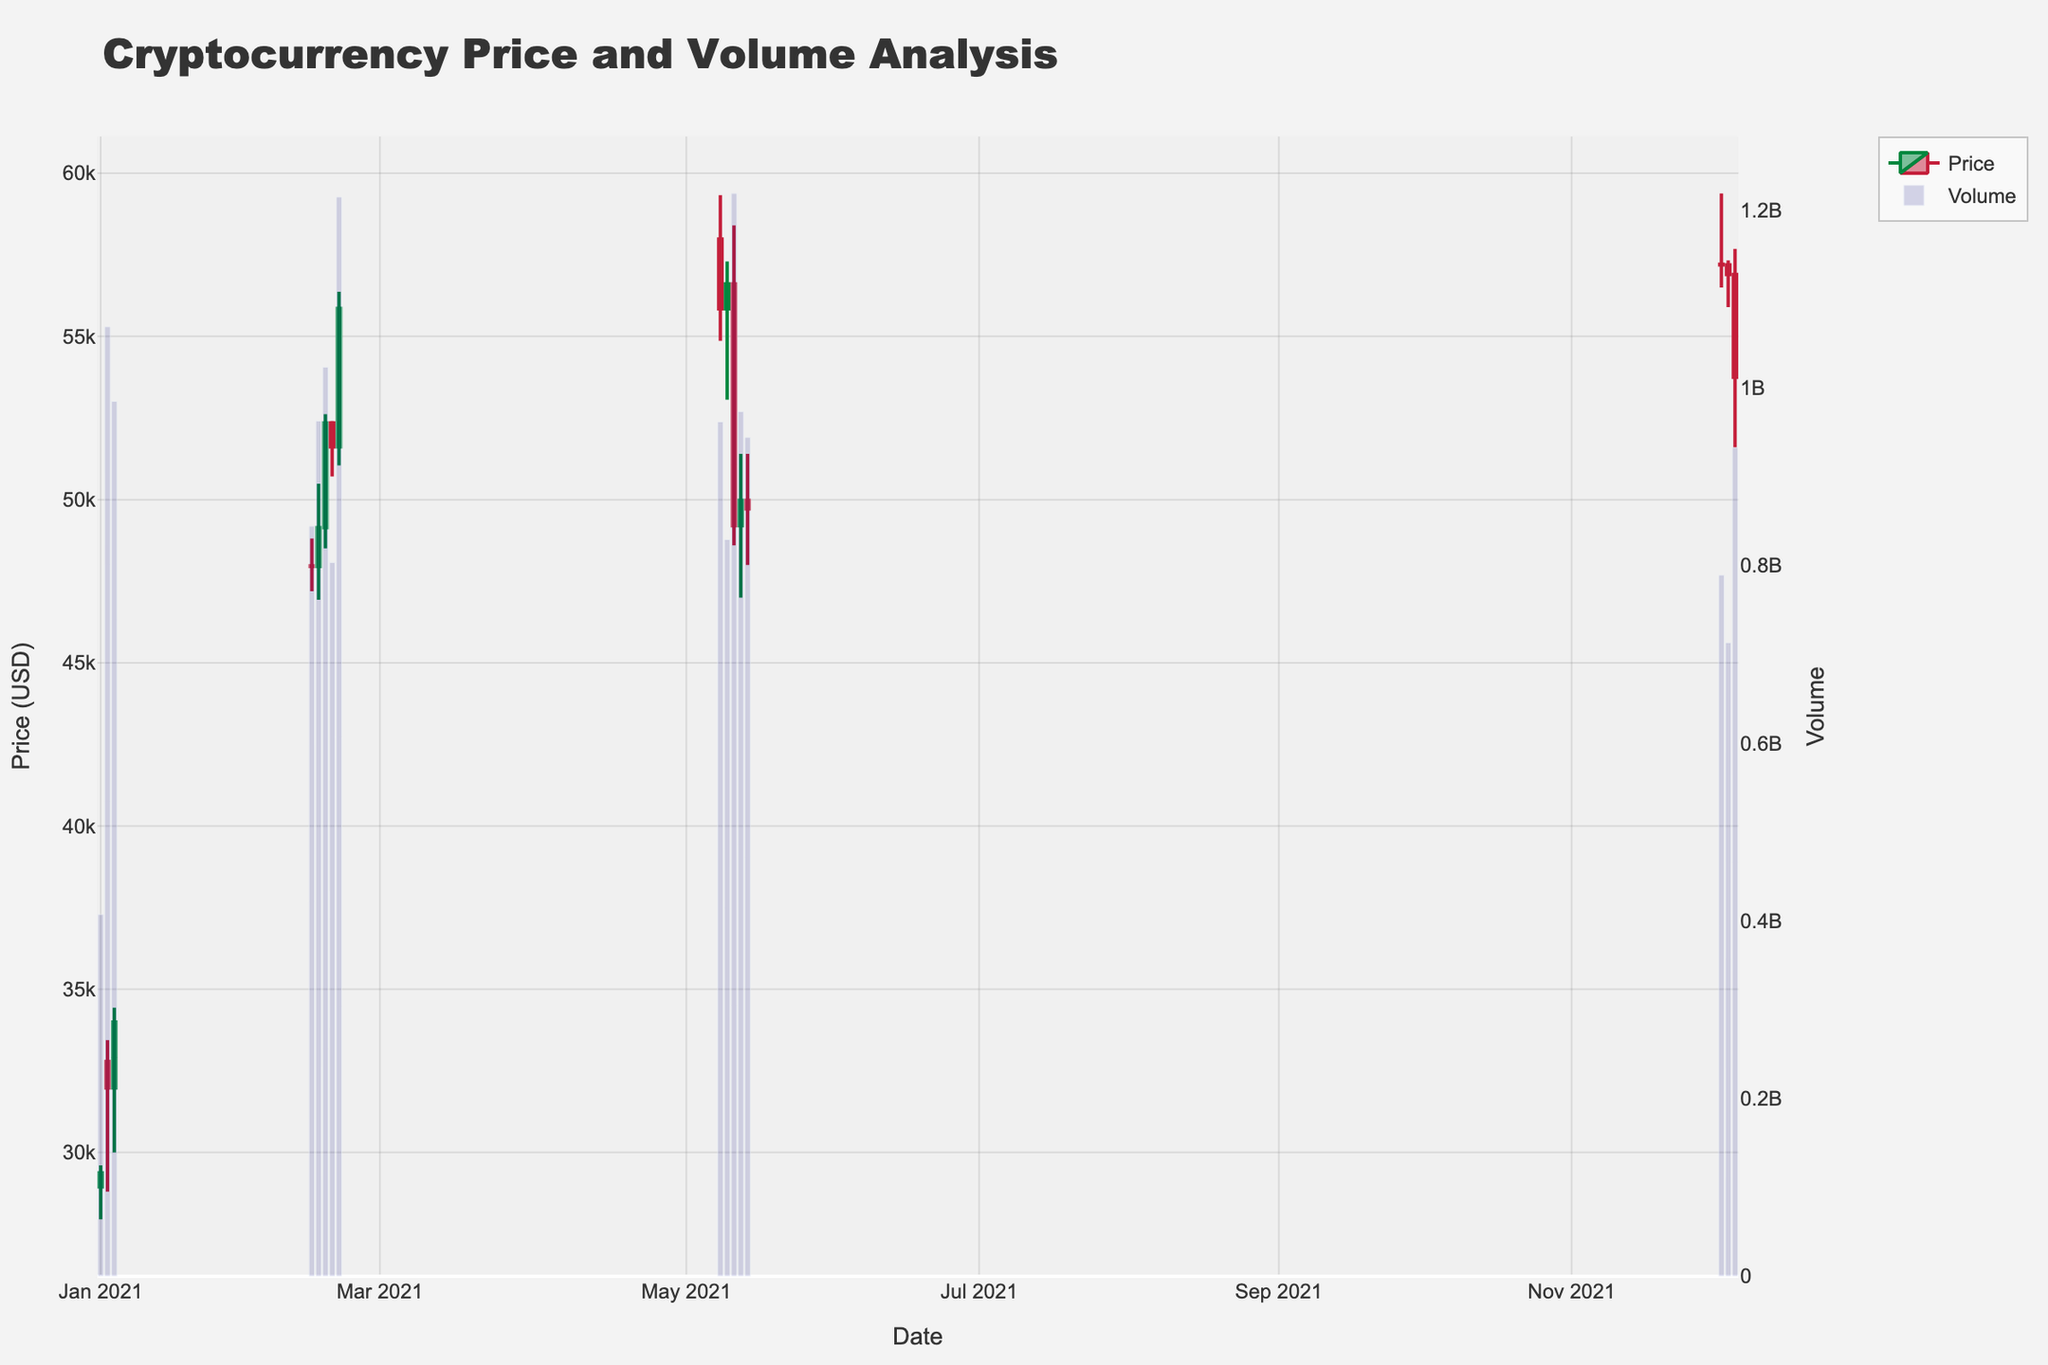What is the title of the figure? The title of the figure is usually at the top center. In this case, the title is "Cryptocurrency Price and Volume Analysis".
Answer: Cryptocurrency Price and Volume Analysis What is the color of the increasing price candlesticks? The increasing price candlesticks are colored in green as indicated by "#00873E" in the data. This is visually perceptible as green color.
Answer: Green How many days are represented in the figure? To determine the number of days, count the number of candlesticks. Each candlestick represents one day, and there are 19 candlesticks.
Answer: 19 On which date was the highest trading volume? Look at the bar heights below the candlesticks, where the highest bar represents the highest volume. This corresponds to December 4, 2021.
Answer: December 4, 2021 What was the range of prices on May 12, 2021? The range of prices on any given day can be determined by looking at the top and bottom of the candlestick for that date. For May 12, 2021, the high was $58,400 and the low was $48,600.
Answer: $48,600 - $58,400 What was the largest single-day closing price increase and on which date did it occur? For this, find the largest difference between consecutive closing prices. The largest increase in closing price occurred from January 2, 2021, to January 3, 2021, (from $32,127.27 to $32,782.02) with an increase of $654.75.
Answer: January 3, 2021 During which specific 5-day period did the cryptocurrency show the highest volatility? Volatility can be observed from the lengths of the candlesticks. The period from May 10 to May 14, 2021, shows high volatility with significant price fluctuations, especially on May 12, 2021, where the low price drastically dropped.
Answer: May 10-14, 2021 Which month recorded the highest closing price? To find the month with the highest closing price, observe the candlesticks for each month. The highest closing price in the dataset is in February 2021 where the closing price reached $55,858 on February 19, 2021.
Answer: February 2021 What correlation can be observed between price changes and trading volume from the figure? By observing the figure, high trading volumes often coincide with significant price changes, indicating that large movements in price can trigger higher trading volumes. This can be seen on dates like January 4, 2021, and May 12, 2021.
Answer: High price changes often coincide with higher trading volumes On which date did the closing price approximately match the opening price? A doji candlestick, where the opening and closing prices are nearly equal, would indicate this. The date where this is approximately true is January 1, 2021, with an opening of $28,944.73 and a closing of $29,374.15.
Answer: January 1, 2021 